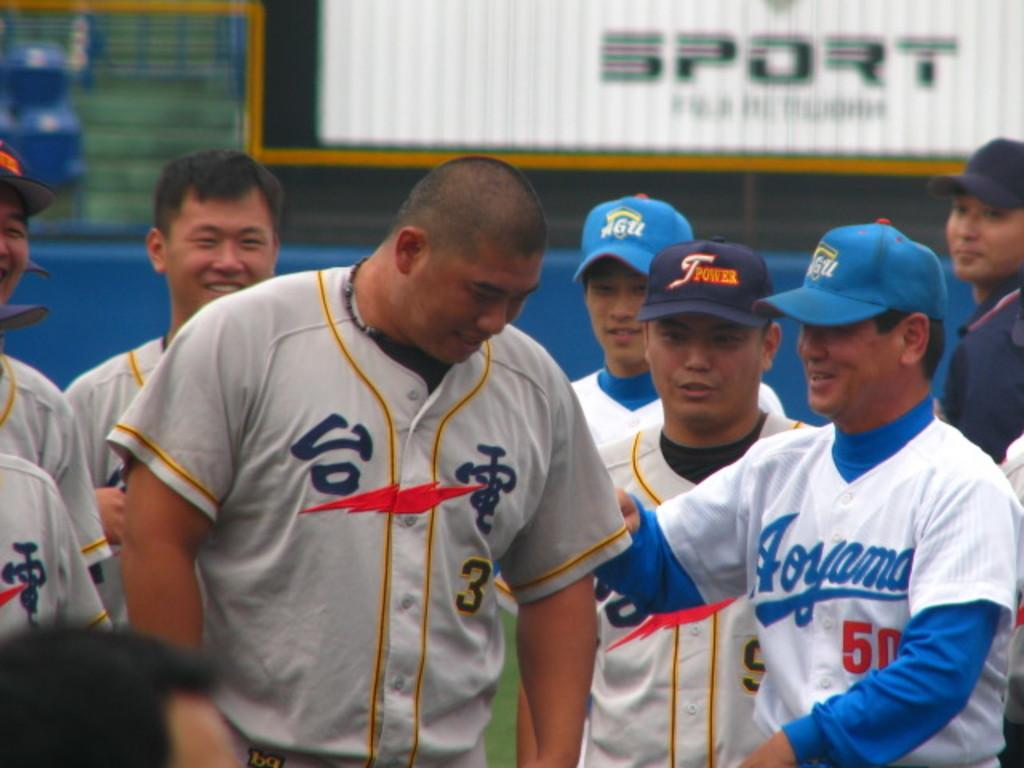<image>
Summarize the visual content of the image. some baseball players including one with the number 50 on their jersey 